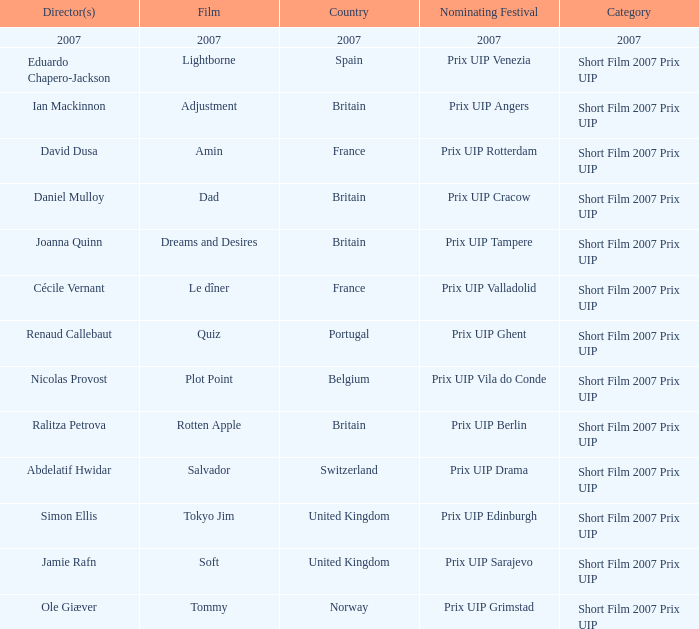What Nominating festival was party of the adjustment film? Prix UIP Angers. 